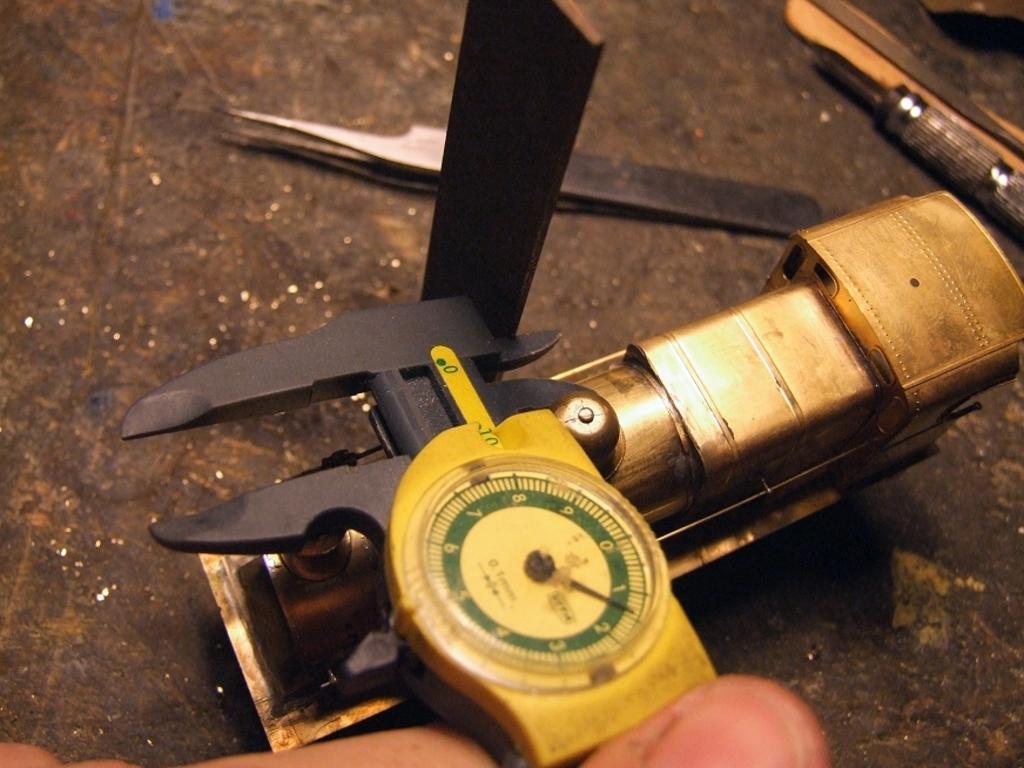Can you describe this image briefly? In this picture there are many tools. In the foreground there is a person's finger. 